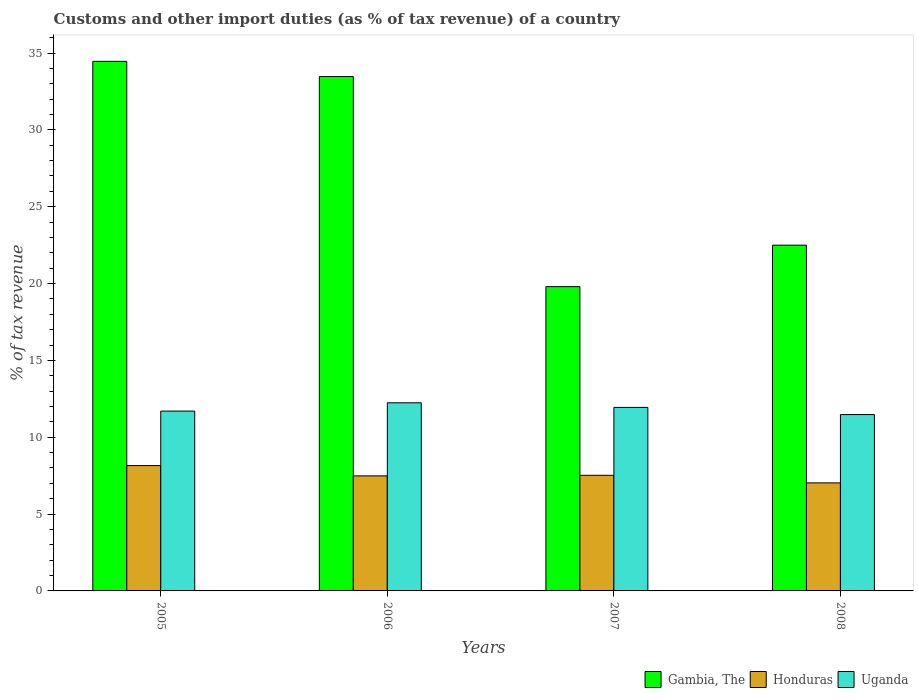How many different coloured bars are there?
Provide a short and direct response. 3. Are the number of bars per tick equal to the number of legend labels?
Offer a terse response. Yes. Are the number of bars on each tick of the X-axis equal?
Offer a terse response. Yes. How many bars are there on the 4th tick from the left?
Make the answer very short. 3. How many bars are there on the 2nd tick from the right?
Your response must be concise. 3. What is the percentage of tax revenue from customs in Gambia, The in 2007?
Make the answer very short. 19.8. Across all years, what is the maximum percentage of tax revenue from customs in Gambia, The?
Your answer should be very brief. 34.46. Across all years, what is the minimum percentage of tax revenue from customs in Uganda?
Make the answer very short. 11.47. In which year was the percentage of tax revenue from customs in Honduras maximum?
Provide a succinct answer. 2005. In which year was the percentage of tax revenue from customs in Honduras minimum?
Ensure brevity in your answer.  2008. What is the total percentage of tax revenue from customs in Gambia, The in the graph?
Provide a succinct answer. 110.22. What is the difference between the percentage of tax revenue from customs in Honduras in 2005 and that in 2006?
Your response must be concise. 0.67. What is the difference between the percentage of tax revenue from customs in Honduras in 2005 and the percentage of tax revenue from customs in Uganda in 2006?
Keep it short and to the point. -4.08. What is the average percentage of tax revenue from customs in Honduras per year?
Keep it short and to the point. 7.55. In the year 2007, what is the difference between the percentage of tax revenue from customs in Honduras and percentage of tax revenue from customs in Uganda?
Make the answer very short. -4.42. What is the ratio of the percentage of tax revenue from customs in Honduras in 2005 to that in 2008?
Provide a succinct answer. 1.16. Is the difference between the percentage of tax revenue from customs in Honduras in 2006 and 2008 greater than the difference between the percentage of tax revenue from customs in Uganda in 2006 and 2008?
Give a very brief answer. No. What is the difference between the highest and the second highest percentage of tax revenue from customs in Uganda?
Give a very brief answer. 0.3. What is the difference between the highest and the lowest percentage of tax revenue from customs in Uganda?
Offer a terse response. 0.77. In how many years, is the percentage of tax revenue from customs in Honduras greater than the average percentage of tax revenue from customs in Honduras taken over all years?
Provide a short and direct response. 1. What does the 2nd bar from the left in 2005 represents?
Your answer should be compact. Honduras. What does the 3rd bar from the right in 2006 represents?
Provide a short and direct response. Gambia, The. Is it the case that in every year, the sum of the percentage of tax revenue from customs in Uganda and percentage of tax revenue from customs in Honduras is greater than the percentage of tax revenue from customs in Gambia, The?
Offer a terse response. No. How many years are there in the graph?
Your response must be concise. 4. Are the values on the major ticks of Y-axis written in scientific E-notation?
Offer a very short reply. No. Does the graph contain any zero values?
Your answer should be compact. No. Does the graph contain grids?
Ensure brevity in your answer.  No. How many legend labels are there?
Ensure brevity in your answer.  3. How are the legend labels stacked?
Make the answer very short. Horizontal. What is the title of the graph?
Ensure brevity in your answer.  Customs and other import duties (as % of tax revenue) of a country. What is the label or title of the X-axis?
Give a very brief answer. Years. What is the label or title of the Y-axis?
Provide a short and direct response. % of tax revenue. What is the % of tax revenue in Gambia, The in 2005?
Your answer should be very brief. 34.46. What is the % of tax revenue of Honduras in 2005?
Make the answer very short. 8.16. What is the % of tax revenue of Uganda in 2005?
Give a very brief answer. 11.7. What is the % of tax revenue of Gambia, The in 2006?
Your answer should be very brief. 33.47. What is the % of tax revenue of Honduras in 2006?
Provide a short and direct response. 7.48. What is the % of tax revenue in Uganda in 2006?
Provide a succinct answer. 12.24. What is the % of tax revenue of Gambia, The in 2007?
Your response must be concise. 19.8. What is the % of tax revenue in Honduras in 2007?
Your answer should be compact. 7.52. What is the % of tax revenue in Uganda in 2007?
Make the answer very short. 11.94. What is the % of tax revenue of Gambia, The in 2008?
Your response must be concise. 22.5. What is the % of tax revenue of Honduras in 2008?
Provide a succinct answer. 7.03. What is the % of tax revenue of Uganda in 2008?
Provide a succinct answer. 11.47. Across all years, what is the maximum % of tax revenue in Gambia, The?
Provide a succinct answer. 34.46. Across all years, what is the maximum % of tax revenue of Honduras?
Your response must be concise. 8.16. Across all years, what is the maximum % of tax revenue in Uganda?
Ensure brevity in your answer.  12.24. Across all years, what is the minimum % of tax revenue of Gambia, The?
Your answer should be compact. 19.8. Across all years, what is the minimum % of tax revenue of Honduras?
Keep it short and to the point. 7.03. Across all years, what is the minimum % of tax revenue in Uganda?
Your response must be concise. 11.47. What is the total % of tax revenue of Gambia, The in the graph?
Ensure brevity in your answer.  110.22. What is the total % of tax revenue of Honduras in the graph?
Your answer should be very brief. 30.19. What is the total % of tax revenue of Uganda in the graph?
Provide a short and direct response. 47.36. What is the difference between the % of tax revenue in Gambia, The in 2005 and that in 2006?
Your answer should be very brief. 0.99. What is the difference between the % of tax revenue of Honduras in 2005 and that in 2006?
Ensure brevity in your answer.  0.67. What is the difference between the % of tax revenue in Uganda in 2005 and that in 2006?
Provide a succinct answer. -0.54. What is the difference between the % of tax revenue of Gambia, The in 2005 and that in 2007?
Your answer should be very brief. 14.66. What is the difference between the % of tax revenue of Honduras in 2005 and that in 2007?
Give a very brief answer. 0.63. What is the difference between the % of tax revenue of Uganda in 2005 and that in 2007?
Keep it short and to the point. -0.24. What is the difference between the % of tax revenue in Gambia, The in 2005 and that in 2008?
Give a very brief answer. 11.96. What is the difference between the % of tax revenue in Honduras in 2005 and that in 2008?
Provide a short and direct response. 1.13. What is the difference between the % of tax revenue in Uganda in 2005 and that in 2008?
Make the answer very short. 0.23. What is the difference between the % of tax revenue of Gambia, The in 2006 and that in 2007?
Your answer should be compact. 13.67. What is the difference between the % of tax revenue of Honduras in 2006 and that in 2007?
Keep it short and to the point. -0.04. What is the difference between the % of tax revenue in Uganda in 2006 and that in 2007?
Offer a terse response. 0.3. What is the difference between the % of tax revenue of Gambia, The in 2006 and that in 2008?
Provide a short and direct response. 10.97. What is the difference between the % of tax revenue in Honduras in 2006 and that in 2008?
Make the answer very short. 0.46. What is the difference between the % of tax revenue in Uganda in 2006 and that in 2008?
Provide a succinct answer. 0.77. What is the difference between the % of tax revenue in Gambia, The in 2007 and that in 2008?
Offer a terse response. -2.7. What is the difference between the % of tax revenue of Honduras in 2007 and that in 2008?
Give a very brief answer. 0.49. What is the difference between the % of tax revenue of Uganda in 2007 and that in 2008?
Make the answer very short. 0.47. What is the difference between the % of tax revenue in Gambia, The in 2005 and the % of tax revenue in Honduras in 2006?
Offer a very short reply. 26.97. What is the difference between the % of tax revenue in Gambia, The in 2005 and the % of tax revenue in Uganda in 2006?
Offer a terse response. 22.22. What is the difference between the % of tax revenue of Honduras in 2005 and the % of tax revenue of Uganda in 2006?
Offer a very short reply. -4.08. What is the difference between the % of tax revenue of Gambia, The in 2005 and the % of tax revenue of Honduras in 2007?
Give a very brief answer. 26.94. What is the difference between the % of tax revenue in Gambia, The in 2005 and the % of tax revenue in Uganda in 2007?
Offer a terse response. 22.52. What is the difference between the % of tax revenue in Honduras in 2005 and the % of tax revenue in Uganda in 2007?
Your answer should be very brief. -3.78. What is the difference between the % of tax revenue in Gambia, The in 2005 and the % of tax revenue in Honduras in 2008?
Keep it short and to the point. 27.43. What is the difference between the % of tax revenue in Gambia, The in 2005 and the % of tax revenue in Uganda in 2008?
Offer a terse response. 22.98. What is the difference between the % of tax revenue in Honduras in 2005 and the % of tax revenue in Uganda in 2008?
Provide a succinct answer. -3.32. What is the difference between the % of tax revenue of Gambia, The in 2006 and the % of tax revenue of Honduras in 2007?
Ensure brevity in your answer.  25.95. What is the difference between the % of tax revenue in Gambia, The in 2006 and the % of tax revenue in Uganda in 2007?
Keep it short and to the point. 21.53. What is the difference between the % of tax revenue of Honduras in 2006 and the % of tax revenue of Uganda in 2007?
Your answer should be very brief. -4.46. What is the difference between the % of tax revenue in Gambia, The in 2006 and the % of tax revenue in Honduras in 2008?
Provide a short and direct response. 26.44. What is the difference between the % of tax revenue in Gambia, The in 2006 and the % of tax revenue in Uganda in 2008?
Give a very brief answer. 22. What is the difference between the % of tax revenue of Honduras in 2006 and the % of tax revenue of Uganda in 2008?
Provide a succinct answer. -3.99. What is the difference between the % of tax revenue in Gambia, The in 2007 and the % of tax revenue in Honduras in 2008?
Offer a terse response. 12.77. What is the difference between the % of tax revenue in Gambia, The in 2007 and the % of tax revenue in Uganda in 2008?
Your response must be concise. 8.33. What is the difference between the % of tax revenue of Honduras in 2007 and the % of tax revenue of Uganda in 2008?
Offer a terse response. -3.95. What is the average % of tax revenue in Gambia, The per year?
Provide a short and direct response. 27.56. What is the average % of tax revenue of Honduras per year?
Provide a short and direct response. 7.55. What is the average % of tax revenue of Uganda per year?
Your answer should be compact. 11.84. In the year 2005, what is the difference between the % of tax revenue in Gambia, The and % of tax revenue in Honduras?
Keep it short and to the point. 26.3. In the year 2005, what is the difference between the % of tax revenue of Gambia, The and % of tax revenue of Uganda?
Provide a succinct answer. 22.76. In the year 2005, what is the difference between the % of tax revenue in Honduras and % of tax revenue in Uganda?
Provide a short and direct response. -3.54. In the year 2006, what is the difference between the % of tax revenue of Gambia, The and % of tax revenue of Honduras?
Keep it short and to the point. 25.98. In the year 2006, what is the difference between the % of tax revenue of Gambia, The and % of tax revenue of Uganda?
Offer a terse response. 21.23. In the year 2006, what is the difference between the % of tax revenue of Honduras and % of tax revenue of Uganda?
Offer a very short reply. -4.76. In the year 2007, what is the difference between the % of tax revenue of Gambia, The and % of tax revenue of Honduras?
Give a very brief answer. 12.28. In the year 2007, what is the difference between the % of tax revenue in Gambia, The and % of tax revenue in Uganda?
Your response must be concise. 7.86. In the year 2007, what is the difference between the % of tax revenue in Honduras and % of tax revenue in Uganda?
Your answer should be very brief. -4.42. In the year 2008, what is the difference between the % of tax revenue of Gambia, The and % of tax revenue of Honduras?
Make the answer very short. 15.47. In the year 2008, what is the difference between the % of tax revenue in Gambia, The and % of tax revenue in Uganda?
Make the answer very short. 11.03. In the year 2008, what is the difference between the % of tax revenue of Honduras and % of tax revenue of Uganda?
Your answer should be very brief. -4.44. What is the ratio of the % of tax revenue in Gambia, The in 2005 to that in 2006?
Offer a terse response. 1.03. What is the ratio of the % of tax revenue in Honduras in 2005 to that in 2006?
Make the answer very short. 1.09. What is the ratio of the % of tax revenue of Uganda in 2005 to that in 2006?
Keep it short and to the point. 0.96. What is the ratio of the % of tax revenue of Gambia, The in 2005 to that in 2007?
Give a very brief answer. 1.74. What is the ratio of the % of tax revenue in Honduras in 2005 to that in 2007?
Ensure brevity in your answer.  1.08. What is the ratio of the % of tax revenue in Uganda in 2005 to that in 2007?
Ensure brevity in your answer.  0.98. What is the ratio of the % of tax revenue in Gambia, The in 2005 to that in 2008?
Make the answer very short. 1.53. What is the ratio of the % of tax revenue of Honduras in 2005 to that in 2008?
Give a very brief answer. 1.16. What is the ratio of the % of tax revenue in Uganda in 2005 to that in 2008?
Your response must be concise. 1.02. What is the ratio of the % of tax revenue in Gambia, The in 2006 to that in 2007?
Your answer should be very brief. 1.69. What is the ratio of the % of tax revenue in Uganda in 2006 to that in 2007?
Your answer should be compact. 1.03. What is the ratio of the % of tax revenue of Gambia, The in 2006 to that in 2008?
Keep it short and to the point. 1.49. What is the ratio of the % of tax revenue of Honduras in 2006 to that in 2008?
Offer a terse response. 1.06. What is the ratio of the % of tax revenue of Uganda in 2006 to that in 2008?
Offer a very short reply. 1.07. What is the ratio of the % of tax revenue of Gambia, The in 2007 to that in 2008?
Ensure brevity in your answer.  0.88. What is the ratio of the % of tax revenue of Honduras in 2007 to that in 2008?
Your answer should be very brief. 1.07. What is the ratio of the % of tax revenue of Uganda in 2007 to that in 2008?
Provide a succinct answer. 1.04. What is the difference between the highest and the second highest % of tax revenue in Honduras?
Keep it short and to the point. 0.63. What is the difference between the highest and the second highest % of tax revenue of Uganda?
Give a very brief answer. 0.3. What is the difference between the highest and the lowest % of tax revenue in Gambia, The?
Ensure brevity in your answer.  14.66. What is the difference between the highest and the lowest % of tax revenue in Honduras?
Your answer should be compact. 1.13. What is the difference between the highest and the lowest % of tax revenue in Uganda?
Provide a succinct answer. 0.77. 